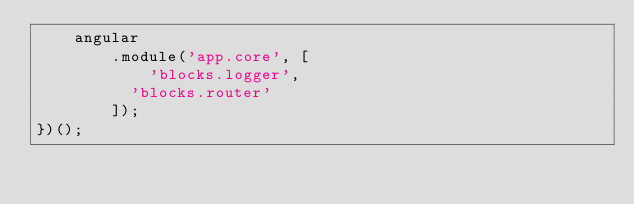<code> <loc_0><loc_0><loc_500><loc_500><_JavaScript_>    angular
        .module('app.core', [
            'blocks.logger',
        	'blocks.router'
        ]);
})();</code> 